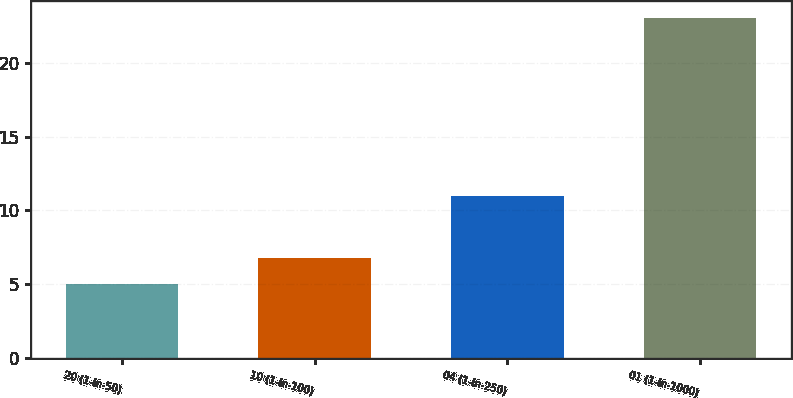Convert chart to OTSL. <chart><loc_0><loc_0><loc_500><loc_500><bar_chart><fcel>20 (1-in-50)<fcel>10 (1-in-100)<fcel>04 (1-in-250)<fcel>01 (1-in-1000)<nl><fcel>5<fcel>6.8<fcel>11<fcel>23<nl></chart> 